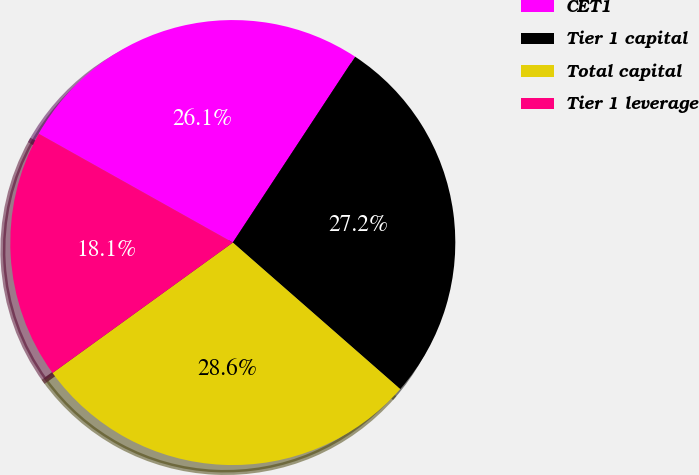Convert chart to OTSL. <chart><loc_0><loc_0><loc_500><loc_500><pie_chart><fcel>CET1<fcel>Tier 1 capital<fcel>Total capital<fcel>Tier 1 leverage<nl><fcel>26.13%<fcel>27.18%<fcel>28.59%<fcel>18.1%<nl></chart> 